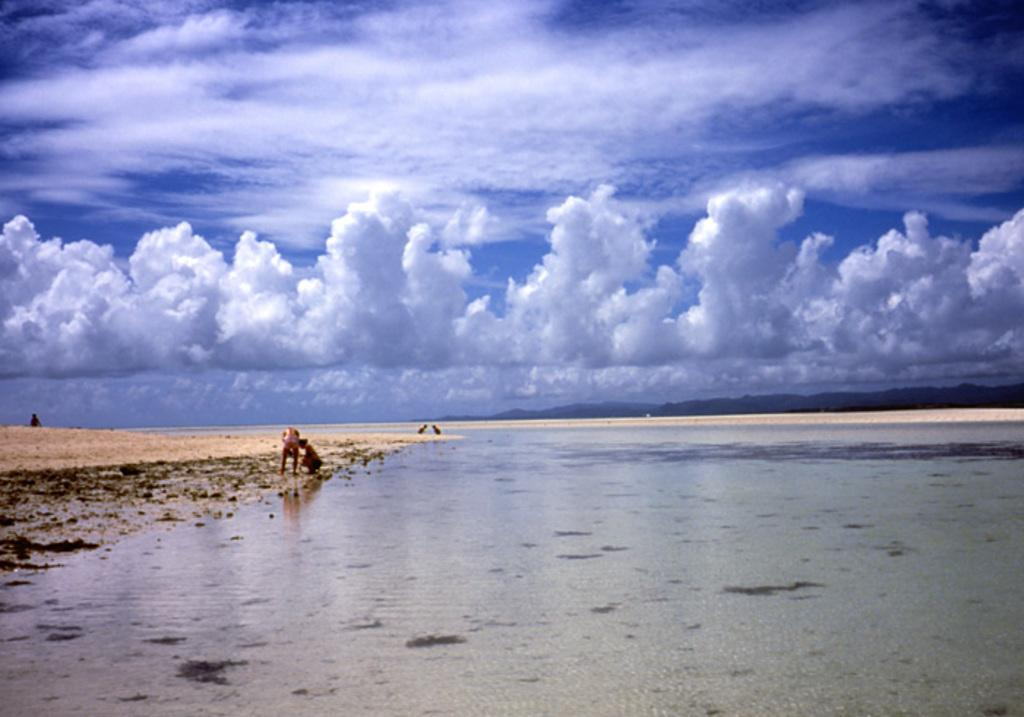What can be seen in the sky in the image? Clouds are visible in the sky in the image. What is the primary element visible in the image? The sky is the primary element visible in the image. How many people are present in the image? There are two persons in the image. What type of body is visible in the image? There is no body visible in the image; it only features clouds and the sky. What force is being applied by the persons in the image? There is no indication of any force being applied by the persons in the image, as they are not performing any actions. 